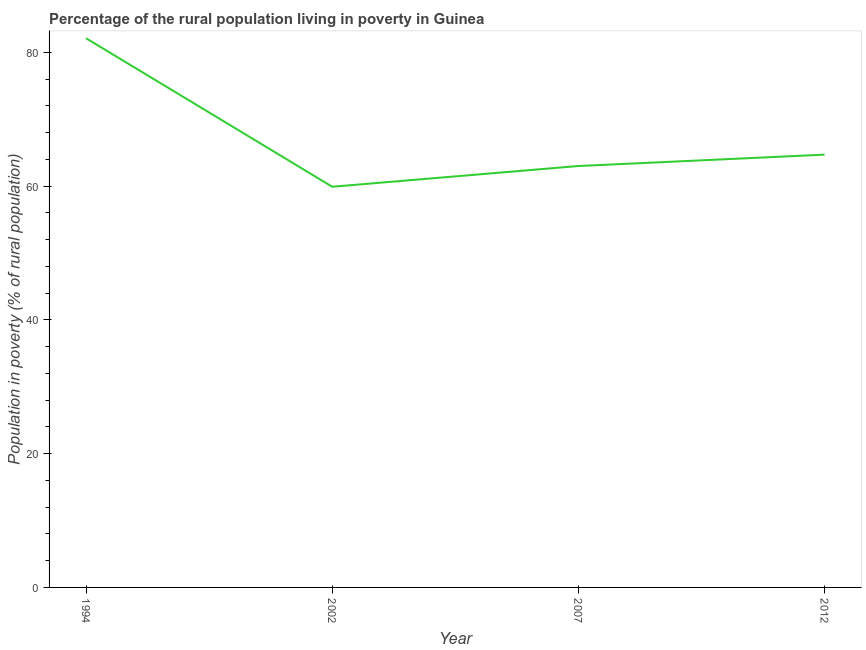Across all years, what is the maximum percentage of rural population living below poverty line?
Your answer should be very brief. 82.1. Across all years, what is the minimum percentage of rural population living below poverty line?
Your response must be concise. 59.9. In which year was the percentage of rural population living below poverty line maximum?
Offer a terse response. 1994. In which year was the percentage of rural population living below poverty line minimum?
Keep it short and to the point. 2002. What is the sum of the percentage of rural population living below poverty line?
Keep it short and to the point. 269.7. What is the difference between the percentage of rural population living below poverty line in 2002 and 2007?
Ensure brevity in your answer.  -3.1. What is the average percentage of rural population living below poverty line per year?
Give a very brief answer. 67.42. What is the median percentage of rural population living below poverty line?
Make the answer very short. 63.85. In how many years, is the percentage of rural population living below poverty line greater than 56 %?
Give a very brief answer. 4. Do a majority of the years between 1994 and 2012 (inclusive) have percentage of rural population living below poverty line greater than 32 %?
Give a very brief answer. Yes. What is the ratio of the percentage of rural population living below poverty line in 2002 to that in 2012?
Give a very brief answer. 0.93. Is the percentage of rural population living below poverty line in 2002 less than that in 2007?
Offer a terse response. Yes. What is the difference between the highest and the second highest percentage of rural population living below poverty line?
Your response must be concise. 17.4. What is the difference between the highest and the lowest percentage of rural population living below poverty line?
Your answer should be compact. 22.2. What is the difference between two consecutive major ticks on the Y-axis?
Provide a short and direct response. 20. Are the values on the major ticks of Y-axis written in scientific E-notation?
Offer a very short reply. No. Does the graph contain any zero values?
Keep it short and to the point. No. What is the title of the graph?
Ensure brevity in your answer.  Percentage of the rural population living in poverty in Guinea. What is the label or title of the X-axis?
Your answer should be compact. Year. What is the label or title of the Y-axis?
Ensure brevity in your answer.  Population in poverty (% of rural population). What is the Population in poverty (% of rural population) in 1994?
Offer a very short reply. 82.1. What is the Population in poverty (% of rural population) of 2002?
Offer a terse response. 59.9. What is the Population in poverty (% of rural population) in 2012?
Make the answer very short. 64.7. What is the difference between the Population in poverty (% of rural population) in 1994 and 2002?
Keep it short and to the point. 22.2. What is the difference between the Population in poverty (% of rural population) in 1994 and 2007?
Your answer should be very brief. 19.1. What is the difference between the Population in poverty (% of rural population) in 2007 and 2012?
Provide a short and direct response. -1.7. What is the ratio of the Population in poverty (% of rural population) in 1994 to that in 2002?
Keep it short and to the point. 1.37. What is the ratio of the Population in poverty (% of rural population) in 1994 to that in 2007?
Offer a terse response. 1.3. What is the ratio of the Population in poverty (% of rural population) in 1994 to that in 2012?
Provide a succinct answer. 1.27. What is the ratio of the Population in poverty (% of rural population) in 2002 to that in 2007?
Keep it short and to the point. 0.95. What is the ratio of the Population in poverty (% of rural population) in 2002 to that in 2012?
Your answer should be compact. 0.93. What is the ratio of the Population in poverty (% of rural population) in 2007 to that in 2012?
Offer a very short reply. 0.97. 